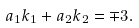<formula> <loc_0><loc_0><loc_500><loc_500>a _ { 1 } k _ { 1 } + a _ { 2 } k _ { 2 } = \mp 3 .</formula> 